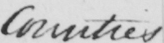Transcribe the text shown in this historical manuscript line. Counties . 